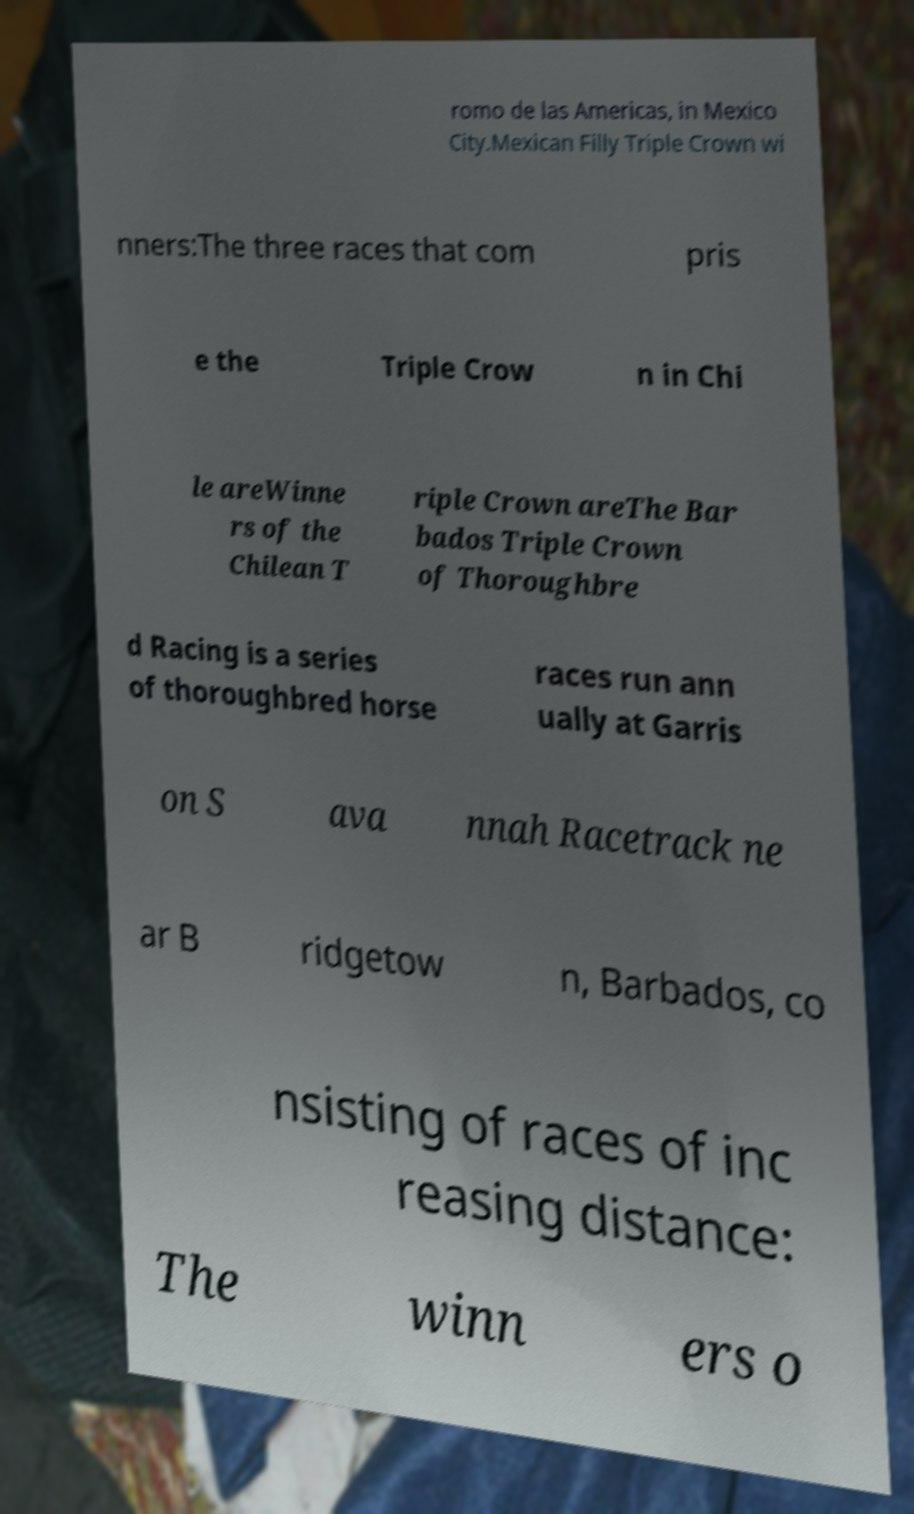I need the written content from this picture converted into text. Can you do that? romo de las Americas, in Mexico City.Mexican Filly Triple Crown wi nners:The three races that com pris e the Triple Crow n in Chi le areWinne rs of the Chilean T riple Crown areThe Bar bados Triple Crown of Thoroughbre d Racing is a series of thoroughbred horse races run ann ually at Garris on S ava nnah Racetrack ne ar B ridgetow n, Barbados, co nsisting of races of inc reasing distance: The winn ers o 